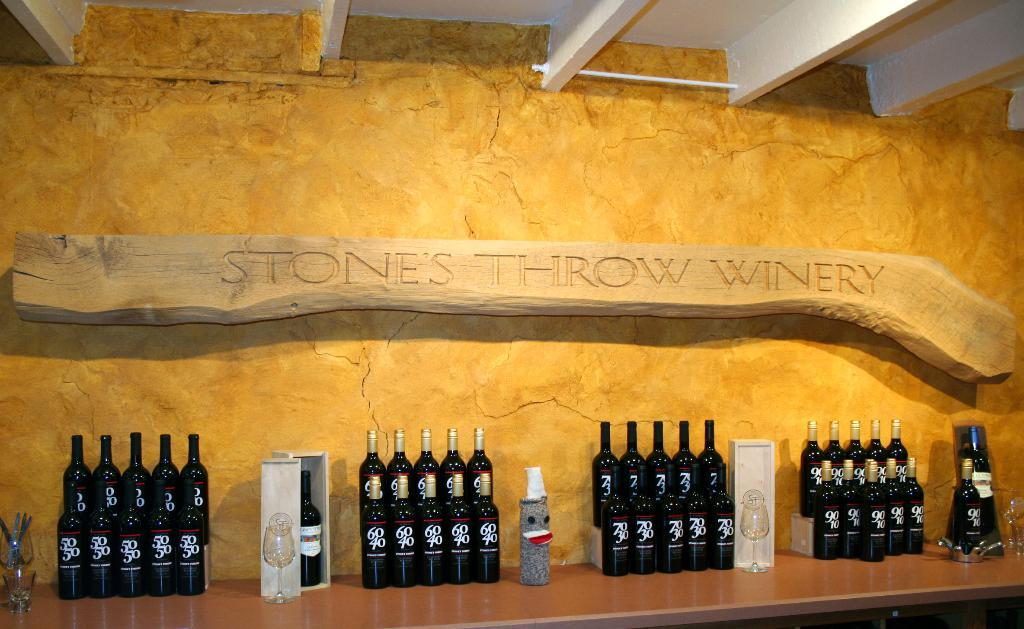<image>
Provide a brief description of the given image. A wooden board saying "Stone's Throw Winery" hangs on a yellow wall. 